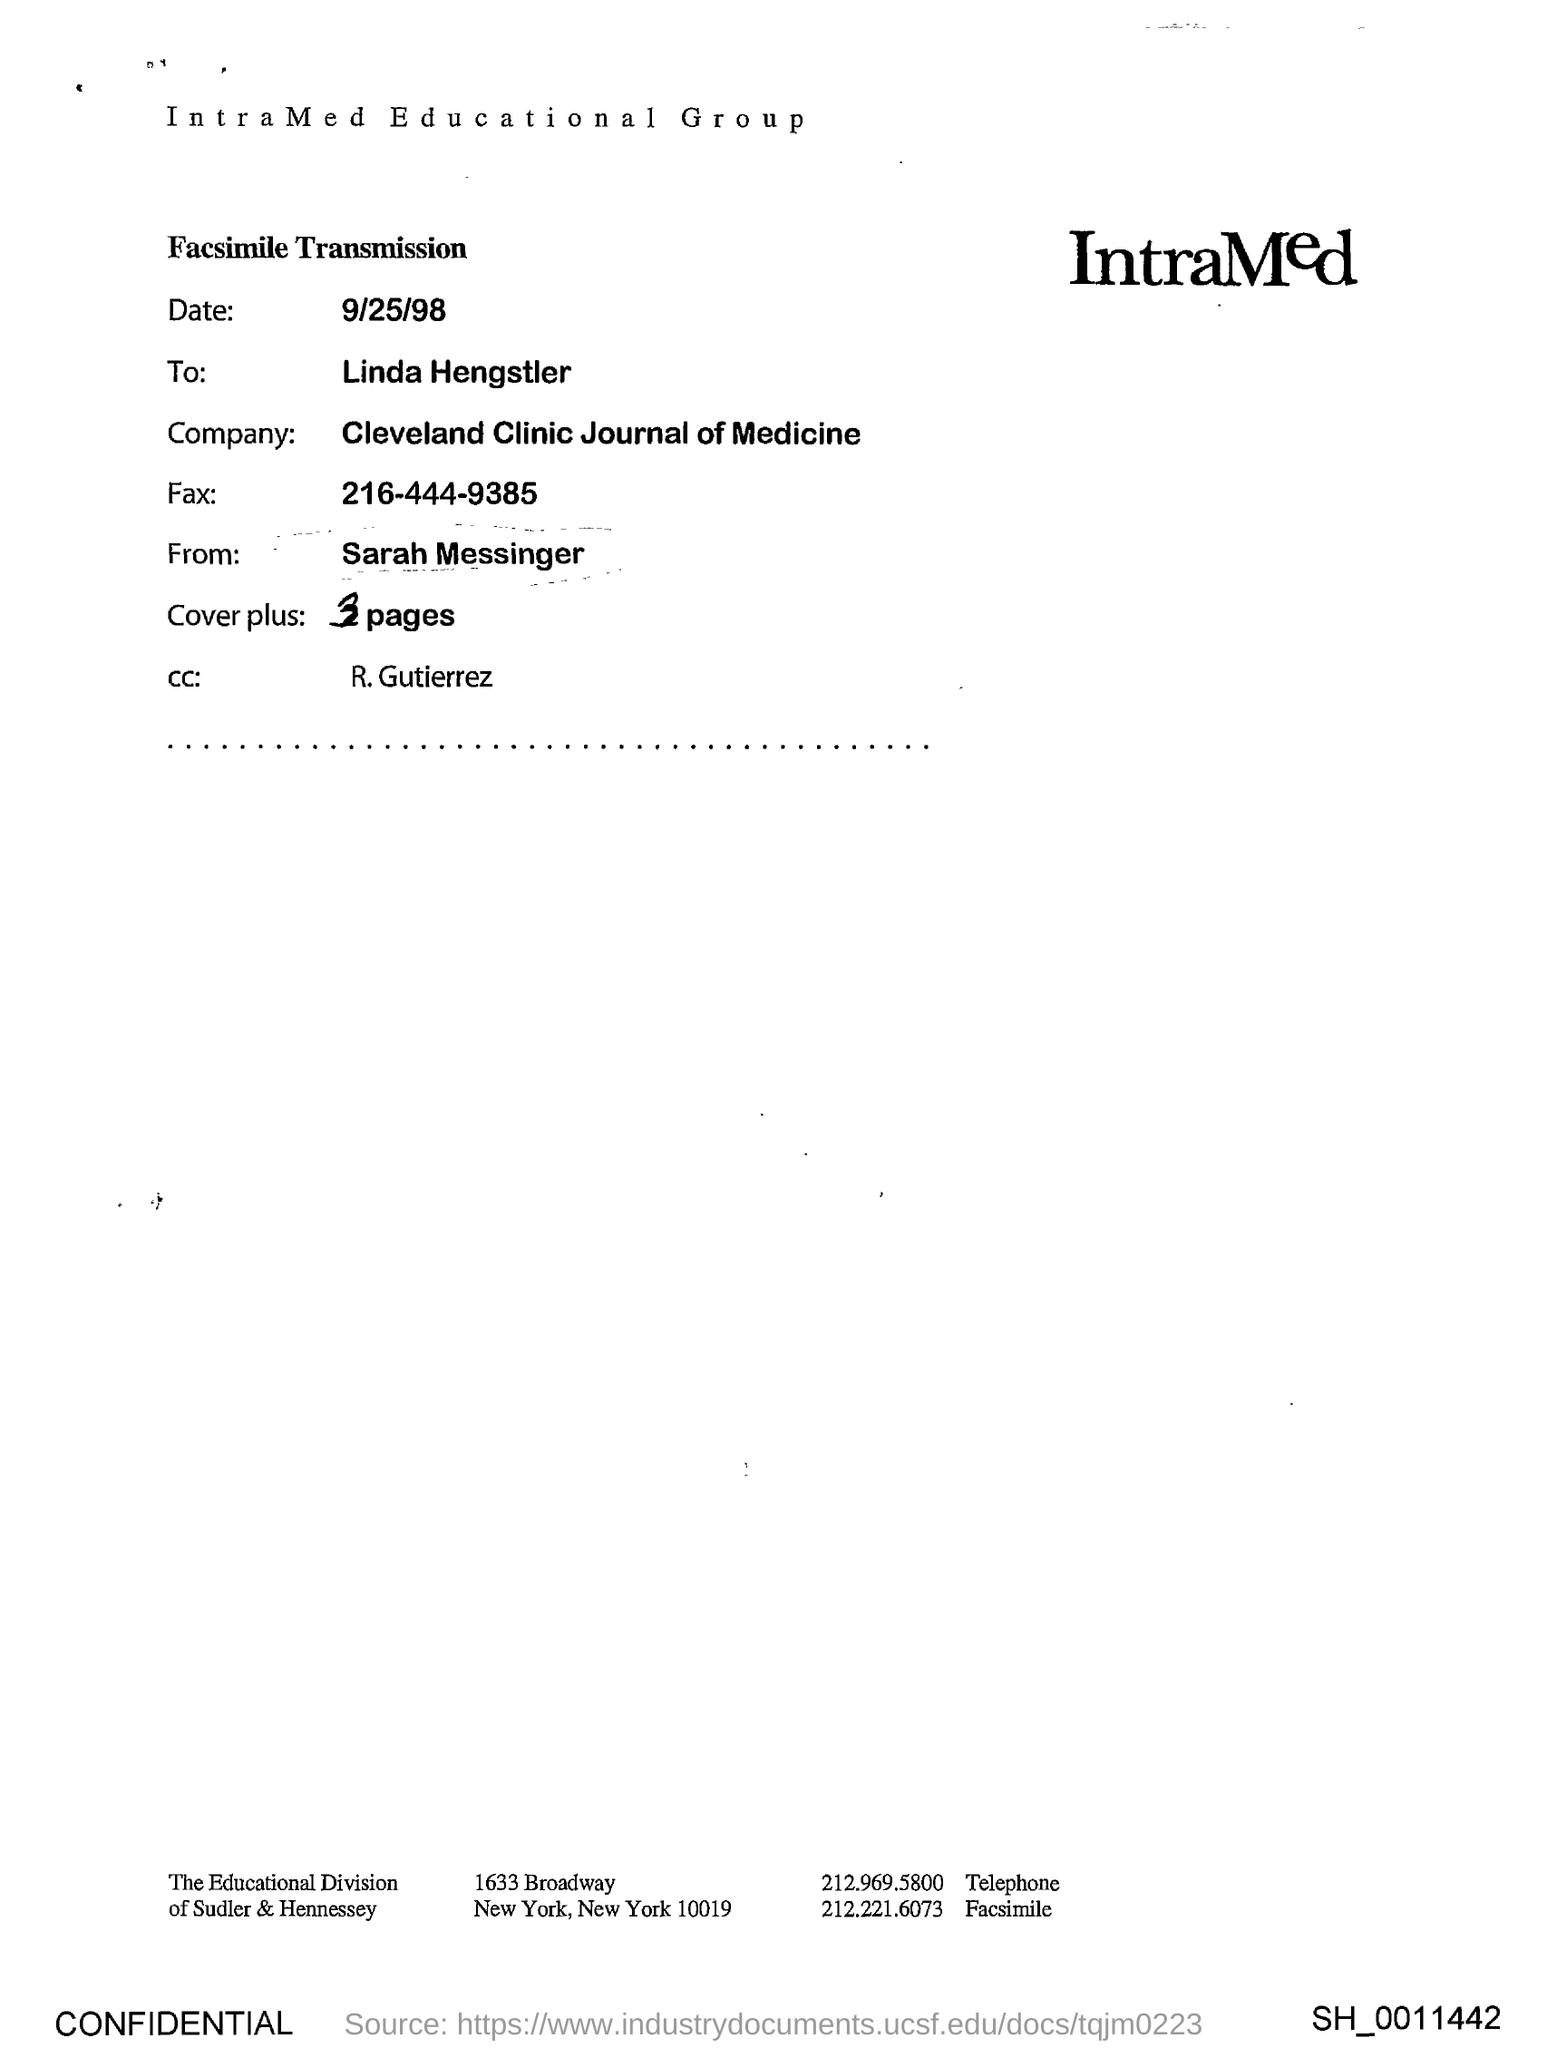What is the date?
Offer a very short reply. 9/25/98. Who is in the CC?
Offer a very short reply. R. Gutierrez. Which company is mentioned in the document?
Your response must be concise. Cleveland Clinic Journal of Medicine. 